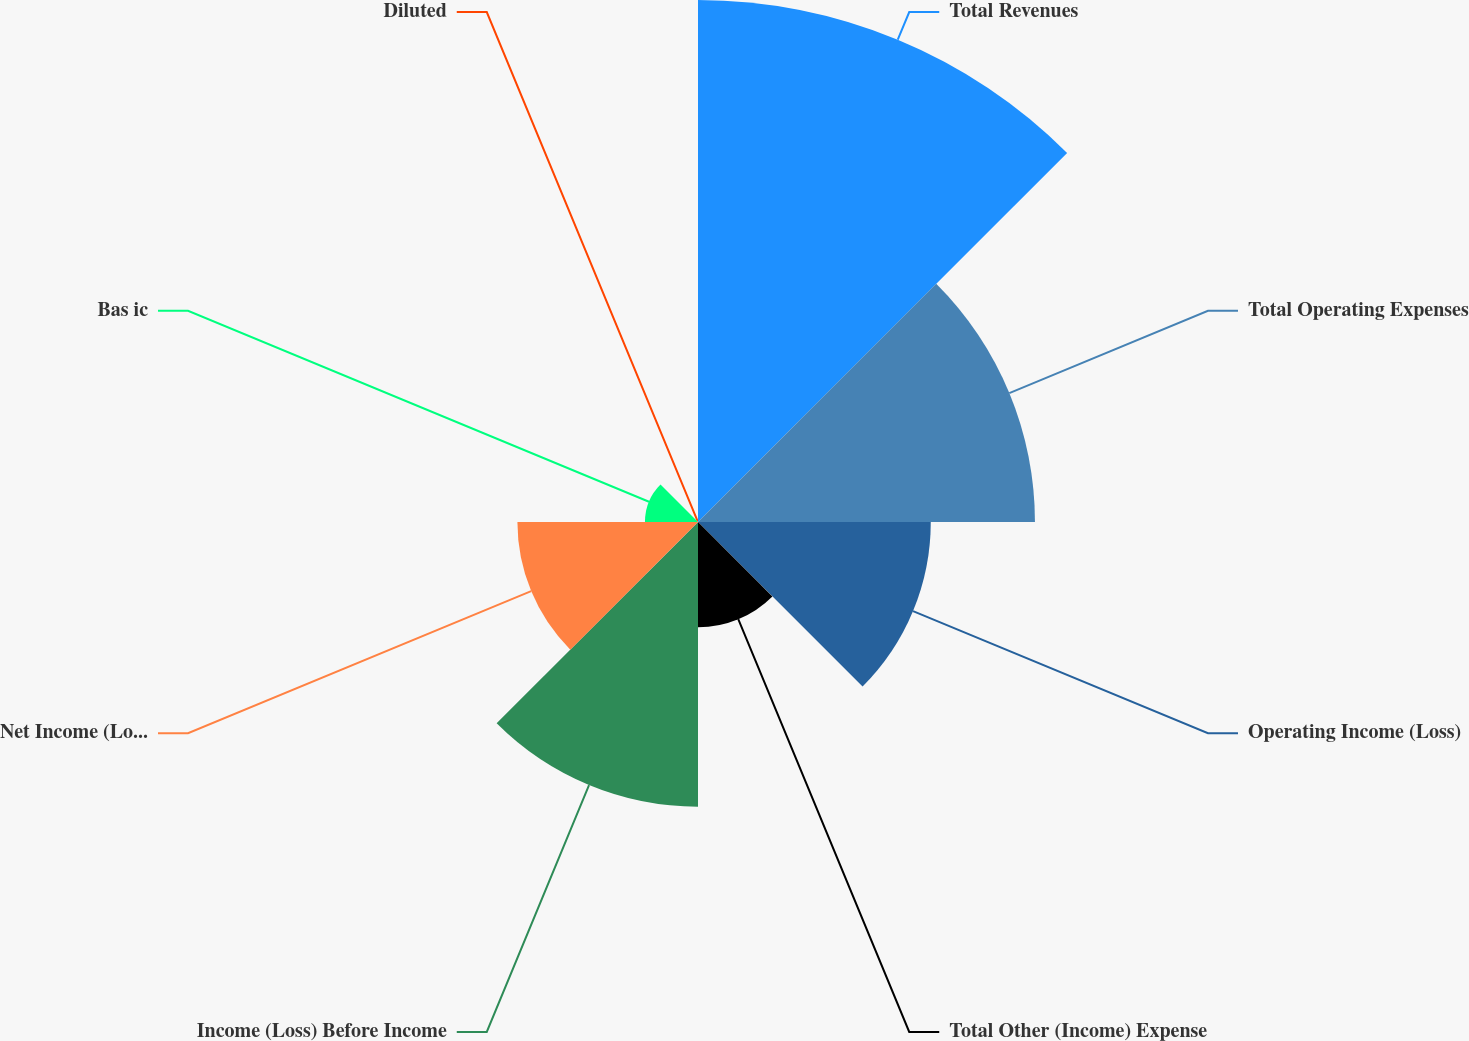Convert chart. <chart><loc_0><loc_0><loc_500><loc_500><pie_chart><fcel>Total Revenues<fcel>Total Operating Expenses<fcel>Operating Income (Loss)<fcel>Total Other (Income) Expense<fcel>Income (Loss) Before Income<fcel>Net Income (Loss)<fcel>Bas ic<fcel>Diluted<nl><fcel>30.41%<fcel>19.63%<fcel>13.56%<fcel>6.13%<fcel>16.59%<fcel>10.52%<fcel>3.09%<fcel>0.06%<nl></chart> 